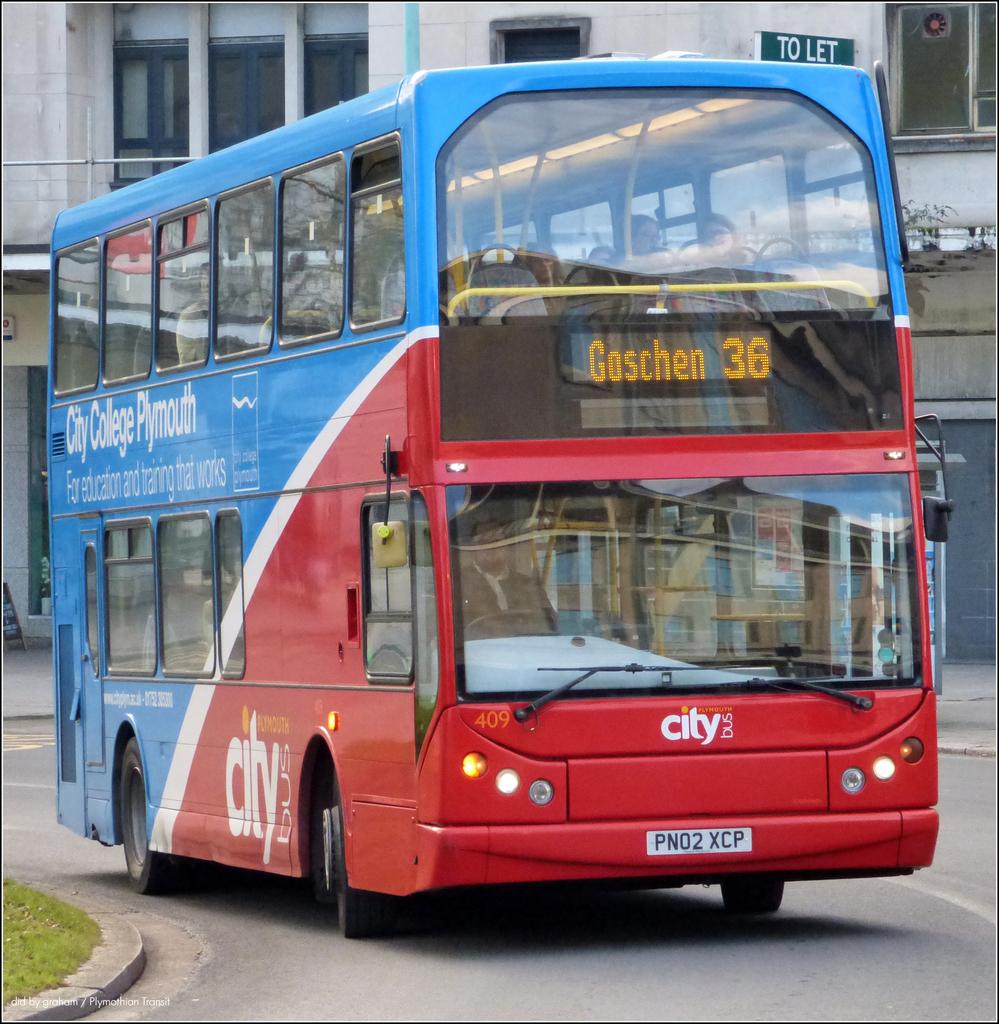What number is this bus?
Offer a terse response. 36. What college is advertised?
Make the answer very short. City college plymouth. 